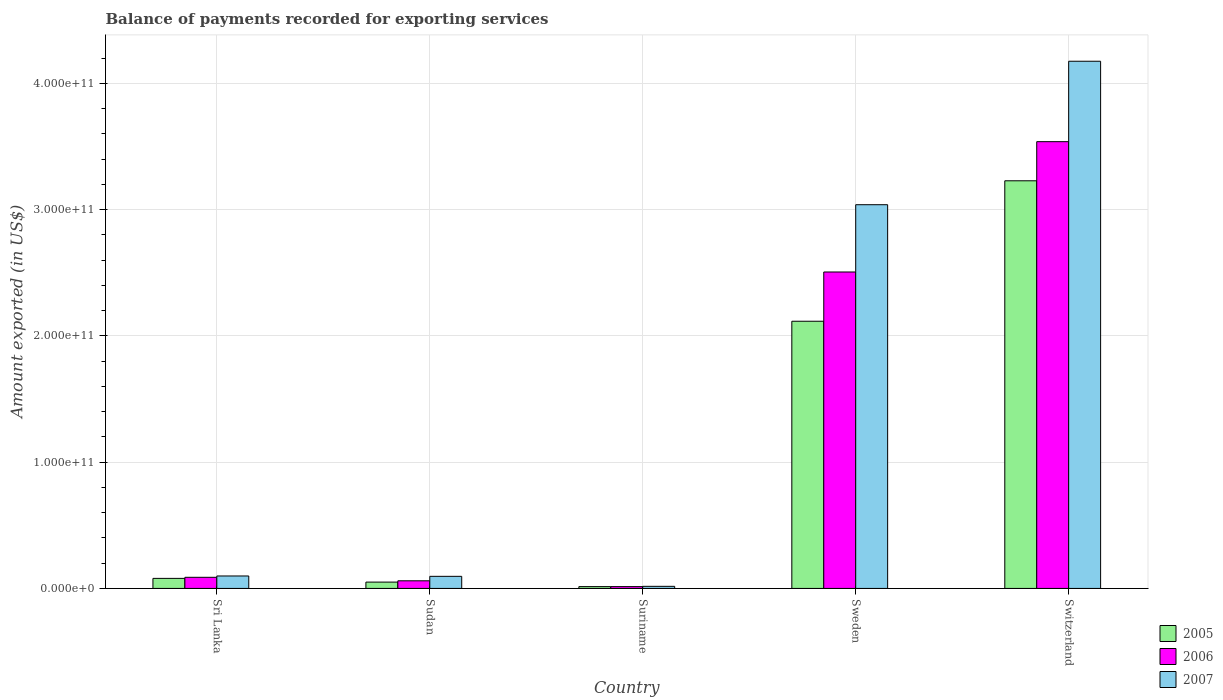How many groups of bars are there?
Provide a succinct answer. 5. Are the number of bars per tick equal to the number of legend labels?
Offer a terse response. Yes. How many bars are there on the 1st tick from the left?
Provide a succinct answer. 3. What is the label of the 1st group of bars from the left?
Ensure brevity in your answer.  Sri Lanka. What is the amount exported in 2005 in Sri Lanka?
Your answer should be compact. 7.96e+09. Across all countries, what is the maximum amount exported in 2005?
Keep it short and to the point. 3.23e+11. Across all countries, what is the minimum amount exported in 2005?
Make the answer very short. 1.44e+09. In which country was the amount exported in 2006 maximum?
Ensure brevity in your answer.  Switzerland. In which country was the amount exported in 2005 minimum?
Provide a succinct answer. Suriname. What is the total amount exported in 2007 in the graph?
Your response must be concise. 7.42e+11. What is the difference between the amount exported in 2007 in Sudan and that in Suriname?
Your answer should be very brief. 7.93e+09. What is the difference between the amount exported in 2006 in Sri Lanka and the amount exported in 2005 in Suriname?
Your response must be concise. 7.38e+09. What is the average amount exported in 2006 per country?
Provide a succinct answer. 1.24e+11. What is the difference between the amount exported of/in 2006 and amount exported of/in 2005 in Switzerland?
Offer a terse response. 3.10e+1. What is the ratio of the amount exported in 2007 in Sudan to that in Switzerland?
Make the answer very short. 0.02. Is the amount exported in 2006 in Sri Lanka less than that in Switzerland?
Make the answer very short. Yes. Is the difference between the amount exported in 2006 in Sudan and Sweden greater than the difference between the amount exported in 2005 in Sudan and Sweden?
Your response must be concise. No. What is the difference between the highest and the second highest amount exported in 2006?
Provide a succinct answer. 3.45e+11. What is the difference between the highest and the lowest amount exported in 2006?
Offer a very short reply. 3.52e+11. What does the 2nd bar from the right in Sudan represents?
Your answer should be compact. 2006. Are all the bars in the graph horizontal?
Offer a terse response. No. How many countries are there in the graph?
Keep it short and to the point. 5. What is the difference between two consecutive major ticks on the Y-axis?
Provide a succinct answer. 1.00e+11. Are the values on the major ticks of Y-axis written in scientific E-notation?
Your answer should be compact. Yes. Does the graph contain any zero values?
Your response must be concise. No. Does the graph contain grids?
Give a very brief answer. Yes. What is the title of the graph?
Provide a short and direct response. Balance of payments recorded for exporting services. Does "2003" appear as one of the legend labels in the graph?
Keep it short and to the point. No. What is the label or title of the Y-axis?
Make the answer very short. Amount exported (in US$). What is the Amount exported (in US$) of 2005 in Sri Lanka?
Offer a very short reply. 7.96e+09. What is the Amount exported (in US$) of 2006 in Sri Lanka?
Offer a terse response. 8.82e+09. What is the Amount exported (in US$) in 2007 in Sri Lanka?
Your answer should be compact. 9.86e+09. What is the Amount exported (in US$) of 2005 in Sudan?
Offer a very short reply. 5.02e+09. What is the Amount exported (in US$) in 2006 in Sudan?
Provide a short and direct response. 6.04e+09. What is the Amount exported (in US$) of 2007 in Sudan?
Your answer should be very brief. 9.58e+09. What is the Amount exported (in US$) in 2005 in Suriname?
Your response must be concise. 1.44e+09. What is the Amount exported (in US$) in 2006 in Suriname?
Provide a succinct answer. 1.44e+09. What is the Amount exported (in US$) of 2007 in Suriname?
Keep it short and to the point. 1.66e+09. What is the Amount exported (in US$) of 2005 in Sweden?
Provide a short and direct response. 2.12e+11. What is the Amount exported (in US$) in 2006 in Sweden?
Ensure brevity in your answer.  2.51e+11. What is the Amount exported (in US$) of 2007 in Sweden?
Your answer should be very brief. 3.04e+11. What is the Amount exported (in US$) in 2005 in Switzerland?
Offer a very short reply. 3.23e+11. What is the Amount exported (in US$) in 2006 in Switzerland?
Offer a terse response. 3.54e+11. What is the Amount exported (in US$) in 2007 in Switzerland?
Make the answer very short. 4.17e+11. Across all countries, what is the maximum Amount exported (in US$) of 2005?
Give a very brief answer. 3.23e+11. Across all countries, what is the maximum Amount exported (in US$) of 2006?
Make the answer very short. 3.54e+11. Across all countries, what is the maximum Amount exported (in US$) of 2007?
Keep it short and to the point. 4.17e+11. Across all countries, what is the minimum Amount exported (in US$) of 2005?
Keep it short and to the point. 1.44e+09. Across all countries, what is the minimum Amount exported (in US$) in 2006?
Ensure brevity in your answer.  1.44e+09. Across all countries, what is the minimum Amount exported (in US$) in 2007?
Provide a short and direct response. 1.66e+09. What is the total Amount exported (in US$) of 2005 in the graph?
Provide a short and direct response. 5.49e+11. What is the total Amount exported (in US$) in 2006 in the graph?
Offer a terse response. 6.21e+11. What is the total Amount exported (in US$) in 2007 in the graph?
Give a very brief answer. 7.42e+11. What is the difference between the Amount exported (in US$) of 2005 in Sri Lanka and that in Sudan?
Provide a succinct answer. 2.94e+09. What is the difference between the Amount exported (in US$) in 2006 in Sri Lanka and that in Sudan?
Make the answer very short. 2.77e+09. What is the difference between the Amount exported (in US$) of 2007 in Sri Lanka and that in Sudan?
Give a very brief answer. 2.82e+08. What is the difference between the Amount exported (in US$) of 2005 in Sri Lanka and that in Suriname?
Your answer should be very brief. 6.52e+09. What is the difference between the Amount exported (in US$) of 2006 in Sri Lanka and that in Suriname?
Offer a terse response. 7.38e+09. What is the difference between the Amount exported (in US$) of 2007 in Sri Lanka and that in Suriname?
Your response must be concise. 8.21e+09. What is the difference between the Amount exported (in US$) in 2005 in Sri Lanka and that in Sweden?
Your response must be concise. -2.04e+11. What is the difference between the Amount exported (in US$) of 2006 in Sri Lanka and that in Sweden?
Provide a short and direct response. -2.42e+11. What is the difference between the Amount exported (in US$) of 2007 in Sri Lanka and that in Sweden?
Your response must be concise. -2.94e+11. What is the difference between the Amount exported (in US$) in 2005 in Sri Lanka and that in Switzerland?
Give a very brief answer. -3.15e+11. What is the difference between the Amount exported (in US$) of 2006 in Sri Lanka and that in Switzerland?
Offer a terse response. -3.45e+11. What is the difference between the Amount exported (in US$) in 2007 in Sri Lanka and that in Switzerland?
Make the answer very short. -4.08e+11. What is the difference between the Amount exported (in US$) of 2005 in Sudan and that in Suriname?
Provide a succinct answer. 3.58e+09. What is the difference between the Amount exported (in US$) of 2006 in Sudan and that in Suriname?
Provide a short and direct response. 4.61e+09. What is the difference between the Amount exported (in US$) of 2007 in Sudan and that in Suriname?
Provide a succinct answer. 7.93e+09. What is the difference between the Amount exported (in US$) in 2005 in Sudan and that in Sweden?
Ensure brevity in your answer.  -2.07e+11. What is the difference between the Amount exported (in US$) in 2006 in Sudan and that in Sweden?
Your response must be concise. -2.45e+11. What is the difference between the Amount exported (in US$) in 2007 in Sudan and that in Sweden?
Provide a succinct answer. -2.94e+11. What is the difference between the Amount exported (in US$) of 2005 in Sudan and that in Switzerland?
Make the answer very short. -3.18e+11. What is the difference between the Amount exported (in US$) of 2006 in Sudan and that in Switzerland?
Your answer should be compact. -3.48e+11. What is the difference between the Amount exported (in US$) in 2007 in Sudan and that in Switzerland?
Offer a terse response. -4.08e+11. What is the difference between the Amount exported (in US$) of 2005 in Suriname and that in Sweden?
Provide a succinct answer. -2.10e+11. What is the difference between the Amount exported (in US$) in 2006 in Suriname and that in Sweden?
Your response must be concise. -2.49e+11. What is the difference between the Amount exported (in US$) of 2007 in Suriname and that in Sweden?
Make the answer very short. -3.02e+11. What is the difference between the Amount exported (in US$) of 2005 in Suriname and that in Switzerland?
Your response must be concise. -3.21e+11. What is the difference between the Amount exported (in US$) of 2006 in Suriname and that in Switzerland?
Offer a very short reply. -3.52e+11. What is the difference between the Amount exported (in US$) of 2007 in Suriname and that in Switzerland?
Your response must be concise. -4.16e+11. What is the difference between the Amount exported (in US$) in 2005 in Sweden and that in Switzerland?
Your answer should be very brief. -1.11e+11. What is the difference between the Amount exported (in US$) in 2006 in Sweden and that in Switzerland?
Offer a very short reply. -1.03e+11. What is the difference between the Amount exported (in US$) in 2007 in Sweden and that in Switzerland?
Provide a short and direct response. -1.14e+11. What is the difference between the Amount exported (in US$) of 2005 in Sri Lanka and the Amount exported (in US$) of 2006 in Sudan?
Provide a succinct answer. 1.92e+09. What is the difference between the Amount exported (in US$) in 2005 in Sri Lanka and the Amount exported (in US$) in 2007 in Sudan?
Your response must be concise. -1.62e+09. What is the difference between the Amount exported (in US$) in 2006 in Sri Lanka and the Amount exported (in US$) in 2007 in Sudan?
Your answer should be compact. -7.63e+08. What is the difference between the Amount exported (in US$) of 2005 in Sri Lanka and the Amount exported (in US$) of 2006 in Suriname?
Make the answer very short. 6.53e+09. What is the difference between the Amount exported (in US$) in 2005 in Sri Lanka and the Amount exported (in US$) in 2007 in Suriname?
Your response must be concise. 6.31e+09. What is the difference between the Amount exported (in US$) of 2006 in Sri Lanka and the Amount exported (in US$) of 2007 in Suriname?
Give a very brief answer. 7.16e+09. What is the difference between the Amount exported (in US$) in 2005 in Sri Lanka and the Amount exported (in US$) in 2006 in Sweden?
Your answer should be compact. -2.43e+11. What is the difference between the Amount exported (in US$) of 2005 in Sri Lanka and the Amount exported (in US$) of 2007 in Sweden?
Your answer should be compact. -2.96e+11. What is the difference between the Amount exported (in US$) in 2006 in Sri Lanka and the Amount exported (in US$) in 2007 in Sweden?
Provide a succinct answer. -2.95e+11. What is the difference between the Amount exported (in US$) in 2005 in Sri Lanka and the Amount exported (in US$) in 2006 in Switzerland?
Offer a very short reply. -3.46e+11. What is the difference between the Amount exported (in US$) in 2005 in Sri Lanka and the Amount exported (in US$) in 2007 in Switzerland?
Your response must be concise. -4.10e+11. What is the difference between the Amount exported (in US$) of 2006 in Sri Lanka and the Amount exported (in US$) of 2007 in Switzerland?
Provide a short and direct response. -4.09e+11. What is the difference between the Amount exported (in US$) in 2005 in Sudan and the Amount exported (in US$) in 2006 in Suriname?
Provide a succinct answer. 3.58e+09. What is the difference between the Amount exported (in US$) of 2005 in Sudan and the Amount exported (in US$) of 2007 in Suriname?
Ensure brevity in your answer.  3.36e+09. What is the difference between the Amount exported (in US$) in 2006 in Sudan and the Amount exported (in US$) in 2007 in Suriname?
Keep it short and to the point. 4.39e+09. What is the difference between the Amount exported (in US$) of 2005 in Sudan and the Amount exported (in US$) of 2006 in Sweden?
Your answer should be compact. -2.46e+11. What is the difference between the Amount exported (in US$) of 2005 in Sudan and the Amount exported (in US$) of 2007 in Sweden?
Make the answer very short. -2.99e+11. What is the difference between the Amount exported (in US$) in 2006 in Sudan and the Amount exported (in US$) in 2007 in Sweden?
Provide a succinct answer. -2.98e+11. What is the difference between the Amount exported (in US$) in 2005 in Sudan and the Amount exported (in US$) in 2006 in Switzerland?
Your response must be concise. -3.49e+11. What is the difference between the Amount exported (in US$) in 2005 in Sudan and the Amount exported (in US$) in 2007 in Switzerland?
Keep it short and to the point. -4.12e+11. What is the difference between the Amount exported (in US$) of 2006 in Sudan and the Amount exported (in US$) of 2007 in Switzerland?
Give a very brief answer. -4.11e+11. What is the difference between the Amount exported (in US$) of 2005 in Suriname and the Amount exported (in US$) of 2006 in Sweden?
Ensure brevity in your answer.  -2.49e+11. What is the difference between the Amount exported (in US$) of 2005 in Suriname and the Amount exported (in US$) of 2007 in Sweden?
Make the answer very short. -3.02e+11. What is the difference between the Amount exported (in US$) in 2006 in Suriname and the Amount exported (in US$) in 2007 in Sweden?
Give a very brief answer. -3.02e+11. What is the difference between the Amount exported (in US$) of 2005 in Suriname and the Amount exported (in US$) of 2006 in Switzerland?
Provide a succinct answer. -3.52e+11. What is the difference between the Amount exported (in US$) of 2005 in Suriname and the Amount exported (in US$) of 2007 in Switzerland?
Your response must be concise. -4.16e+11. What is the difference between the Amount exported (in US$) in 2006 in Suriname and the Amount exported (in US$) in 2007 in Switzerland?
Your answer should be very brief. -4.16e+11. What is the difference between the Amount exported (in US$) in 2005 in Sweden and the Amount exported (in US$) in 2006 in Switzerland?
Ensure brevity in your answer.  -1.42e+11. What is the difference between the Amount exported (in US$) of 2005 in Sweden and the Amount exported (in US$) of 2007 in Switzerland?
Make the answer very short. -2.06e+11. What is the difference between the Amount exported (in US$) of 2006 in Sweden and the Amount exported (in US$) of 2007 in Switzerland?
Provide a short and direct response. -1.67e+11. What is the average Amount exported (in US$) of 2005 per country?
Offer a very short reply. 1.10e+11. What is the average Amount exported (in US$) of 2006 per country?
Your answer should be compact. 1.24e+11. What is the average Amount exported (in US$) of 2007 per country?
Your answer should be compact. 1.48e+11. What is the difference between the Amount exported (in US$) of 2005 and Amount exported (in US$) of 2006 in Sri Lanka?
Give a very brief answer. -8.56e+08. What is the difference between the Amount exported (in US$) in 2005 and Amount exported (in US$) in 2007 in Sri Lanka?
Ensure brevity in your answer.  -1.90e+09. What is the difference between the Amount exported (in US$) in 2006 and Amount exported (in US$) in 2007 in Sri Lanka?
Offer a terse response. -1.04e+09. What is the difference between the Amount exported (in US$) in 2005 and Amount exported (in US$) in 2006 in Sudan?
Provide a succinct answer. -1.03e+09. What is the difference between the Amount exported (in US$) of 2005 and Amount exported (in US$) of 2007 in Sudan?
Your answer should be compact. -4.56e+09. What is the difference between the Amount exported (in US$) of 2006 and Amount exported (in US$) of 2007 in Sudan?
Your answer should be very brief. -3.54e+09. What is the difference between the Amount exported (in US$) of 2005 and Amount exported (in US$) of 2006 in Suriname?
Make the answer very short. 3.50e+06. What is the difference between the Amount exported (in US$) of 2005 and Amount exported (in US$) of 2007 in Suriname?
Offer a very short reply. -2.16e+08. What is the difference between the Amount exported (in US$) in 2006 and Amount exported (in US$) in 2007 in Suriname?
Give a very brief answer. -2.20e+08. What is the difference between the Amount exported (in US$) in 2005 and Amount exported (in US$) in 2006 in Sweden?
Give a very brief answer. -3.90e+1. What is the difference between the Amount exported (in US$) in 2005 and Amount exported (in US$) in 2007 in Sweden?
Make the answer very short. -9.23e+1. What is the difference between the Amount exported (in US$) of 2006 and Amount exported (in US$) of 2007 in Sweden?
Your answer should be very brief. -5.33e+1. What is the difference between the Amount exported (in US$) of 2005 and Amount exported (in US$) of 2006 in Switzerland?
Keep it short and to the point. -3.10e+1. What is the difference between the Amount exported (in US$) of 2005 and Amount exported (in US$) of 2007 in Switzerland?
Your answer should be compact. -9.47e+1. What is the difference between the Amount exported (in US$) in 2006 and Amount exported (in US$) in 2007 in Switzerland?
Give a very brief answer. -6.37e+1. What is the ratio of the Amount exported (in US$) of 2005 in Sri Lanka to that in Sudan?
Make the answer very short. 1.59. What is the ratio of the Amount exported (in US$) in 2006 in Sri Lanka to that in Sudan?
Offer a very short reply. 1.46. What is the ratio of the Amount exported (in US$) of 2007 in Sri Lanka to that in Sudan?
Provide a succinct answer. 1.03. What is the ratio of the Amount exported (in US$) of 2005 in Sri Lanka to that in Suriname?
Keep it short and to the point. 5.53. What is the ratio of the Amount exported (in US$) of 2006 in Sri Lanka to that in Suriname?
Your answer should be compact. 6.14. What is the ratio of the Amount exported (in US$) of 2007 in Sri Lanka to that in Suriname?
Provide a succinct answer. 5.96. What is the ratio of the Amount exported (in US$) in 2005 in Sri Lanka to that in Sweden?
Give a very brief answer. 0.04. What is the ratio of the Amount exported (in US$) in 2006 in Sri Lanka to that in Sweden?
Keep it short and to the point. 0.04. What is the ratio of the Amount exported (in US$) of 2007 in Sri Lanka to that in Sweden?
Offer a very short reply. 0.03. What is the ratio of the Amount exported (in US$) in 2005 in Sri Lanka to that in Switzerland?
Provide a succinct answer. 0.02. What is the ratio of the Amount exported (in US$) in 2006 in Sri Lanka to that in Switzerland?
Make the answer very short. 0.02. What is the ratio of the Amount exported (in US$) of 2007 in Sri Lanka to that in Switzerland?
Your response must be concise. 0.02. What is the ratio of the Amount exported (in US$) in 2005 in Sudan to that in Suriname?
Ensure brevity in your answer.  3.49. What is the ratio of the Amount exported (in US$) of 2006 in Sudan to that in Suriname?
Your answer should be very brief. 4.21. What is the ratio of the Amount exported (in US$) in 2007 in Sudan to that in Suriname?
Ensure brevity in your answer.  5.79. What is the ratio of the Amount exported (in US$) of 2005 in Sudan to that in Sweden?
Keep it short and to the point. 0.02. What is the ratio of the Amount exported (in US$) in 2006 in Sudan to that in Sweden?
Provide a succinct answer. 0.02. What is the ratio of the Amount exported (in US$) of 2007 in Sudan to that in Sweden?
Keep it short and to the point. 0.03. What is the ratio of the Amount exported (in US$) in 2005 in Sudan to that in Switzerland?
Offer a very short reply. 0.02. What is the ratio of the Amount exported (in US$) of 2006 in Sudan to that in Switzerland?
Offer a very short reply. 0.02. What is the ratio of the Amount exported (in US$) in 2007 in Sudan to that in Switzerland?
Your answer should be compact. 0.02. What is the ratio of the Amount exported (in US$) in 2005 in Suriname to that in Sweden?
Make the answer very short. 0.01. What is the ratio of the Amount exported (in US$) of 2006 in Suriname to that in Sweden?
Keep it short and to the point. 0.01. What is the ratio of the Amount exported (in US$) of 2007 in Suriname to that in Sweden?
Offer a very short reply. 0.01. What is the ratio of the Amount exported (in US$) of 2005 in Suriname to that in Switzerland?
Keep it short and to the point. 0. What is the ratio of the Amount exported (in US$) of 2006 in Suriname to that in Switzerland?
Provide a short and direct response. 0. What is the ratio of the Amount exported (in US$) of 2007 in Suriname to that in Switzerland?
Your answer should be very brief. 0. What is the ratio of the Amount exported (in US$) in 2005 in Sweden to that in Switzerland?
Your response must be concise. 0.66. What is the ratio of the Amount exported (in US$) in 2006 in Sweden to that in Switzerland?
Provide a short and direct response. 0.71. What is the ratio of the Amount exported (in US$) in 2007 in Sweden to that in Switzerland?
Your answer should be compact. 0.73. What is the difference between the highest and the second highest Amount exported (in US$) in 2005?
Your answer should be compact. 1.11e+11. What is the difference between the highest and the second highest Amount exported (in US$) of 2006?
Make the answer very short. 1.03e+11. What is the difference between the highest and the second highest Amount exported (in US$) in 2007?
Give a very brief answer. 1.14e+11. What is the difference between the highest and the lowest Amount exported (in US$) in 2005?
Your response must be concise. 3.21e+11. What is the difference between the highest and the lowest Amount exported (in US$) in 2006?
Provide a short and direct response. 3.52e+11. What is the difference between the highest and the lowest Amount exported (in US$) of 2007?
Your answer should be compact. 4.16e+11. 